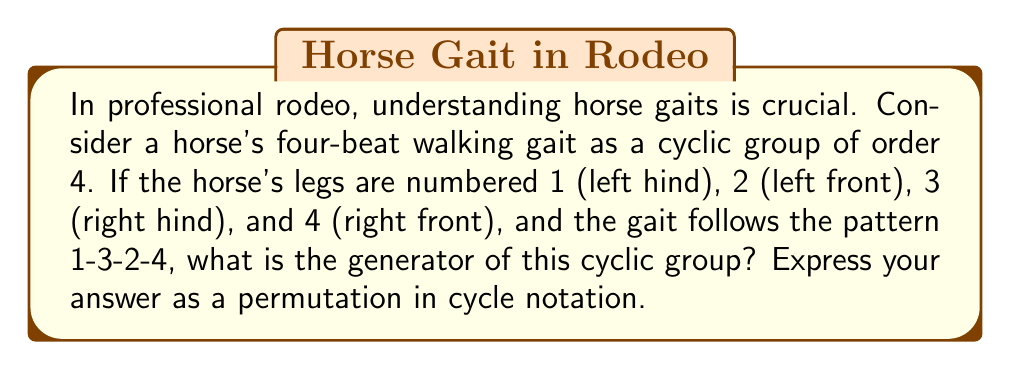Show me your answer to this math problem. Let's approach this step-by-step:

1) First, we need to understand what the gait pattern 1-3-2-4 means. This indicates the order in which the horse's legs move during one complete cycle of the walk.

2) In group theory, we can represent this pattern as a permutation. The permutation takes each leg to the next one in the sequence:
   1 → 3
   3 → 2
   2 → 4
   4 → 1

3) In cycle notation, this permutation is written as $(1324)$.

4) Now, we need to verify that this permutation generates the entire cyclic group of order 4. Let's apply the permutation repeatedly:
   
   $(1324)^1 = (1324)$
   $(1324)^2 = (14)(23)$
   $(1324)^3 = (1432)$
   $(1324)^4 = (1)(2)(3)(4) = e$ (identity)

5) We see that applying the permutation 4 times brings us back to the identity, and each application gives a unique element. This confirms that $(1324)$ generates the entire cyclic group of order 4.

6) Therefore, the generator of this cyclic group representing the horse's walking gait is the permutation $(1324)$.
Answer: $(1324)$ 